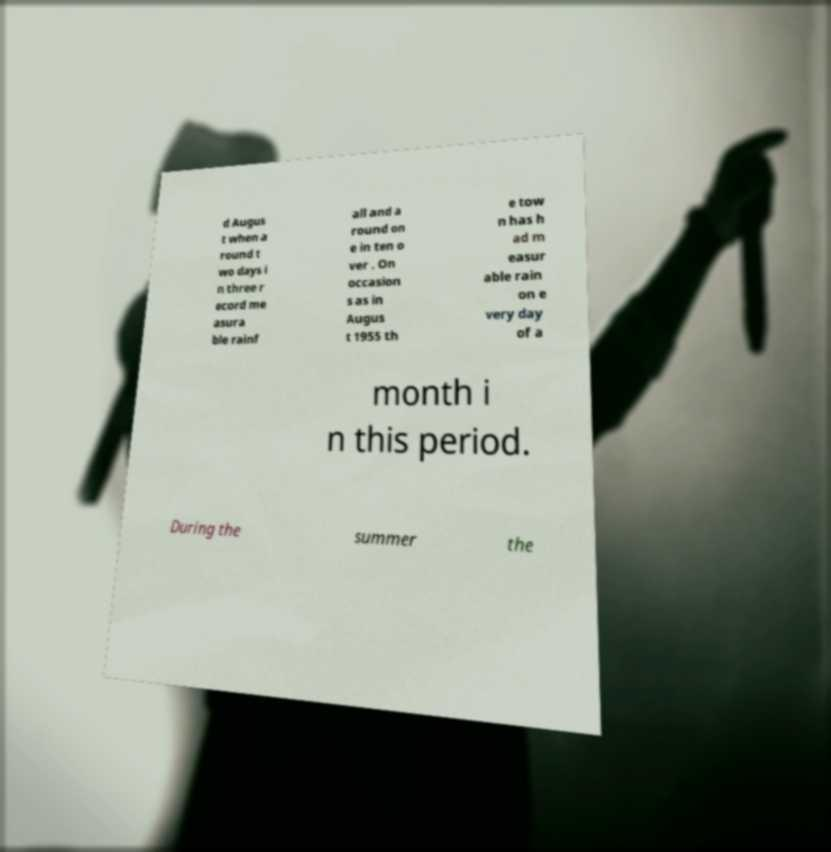Can you accurately transcribe the text from the provided image for me? d Augus t when a round t wo days i n three r ecord me asura ble rainf all and a round on e in ten o ver . On occasion s as in Augus t 1955 th e tow n has h ad m easur able rain on e very day of a month i n this period. During the summer the 